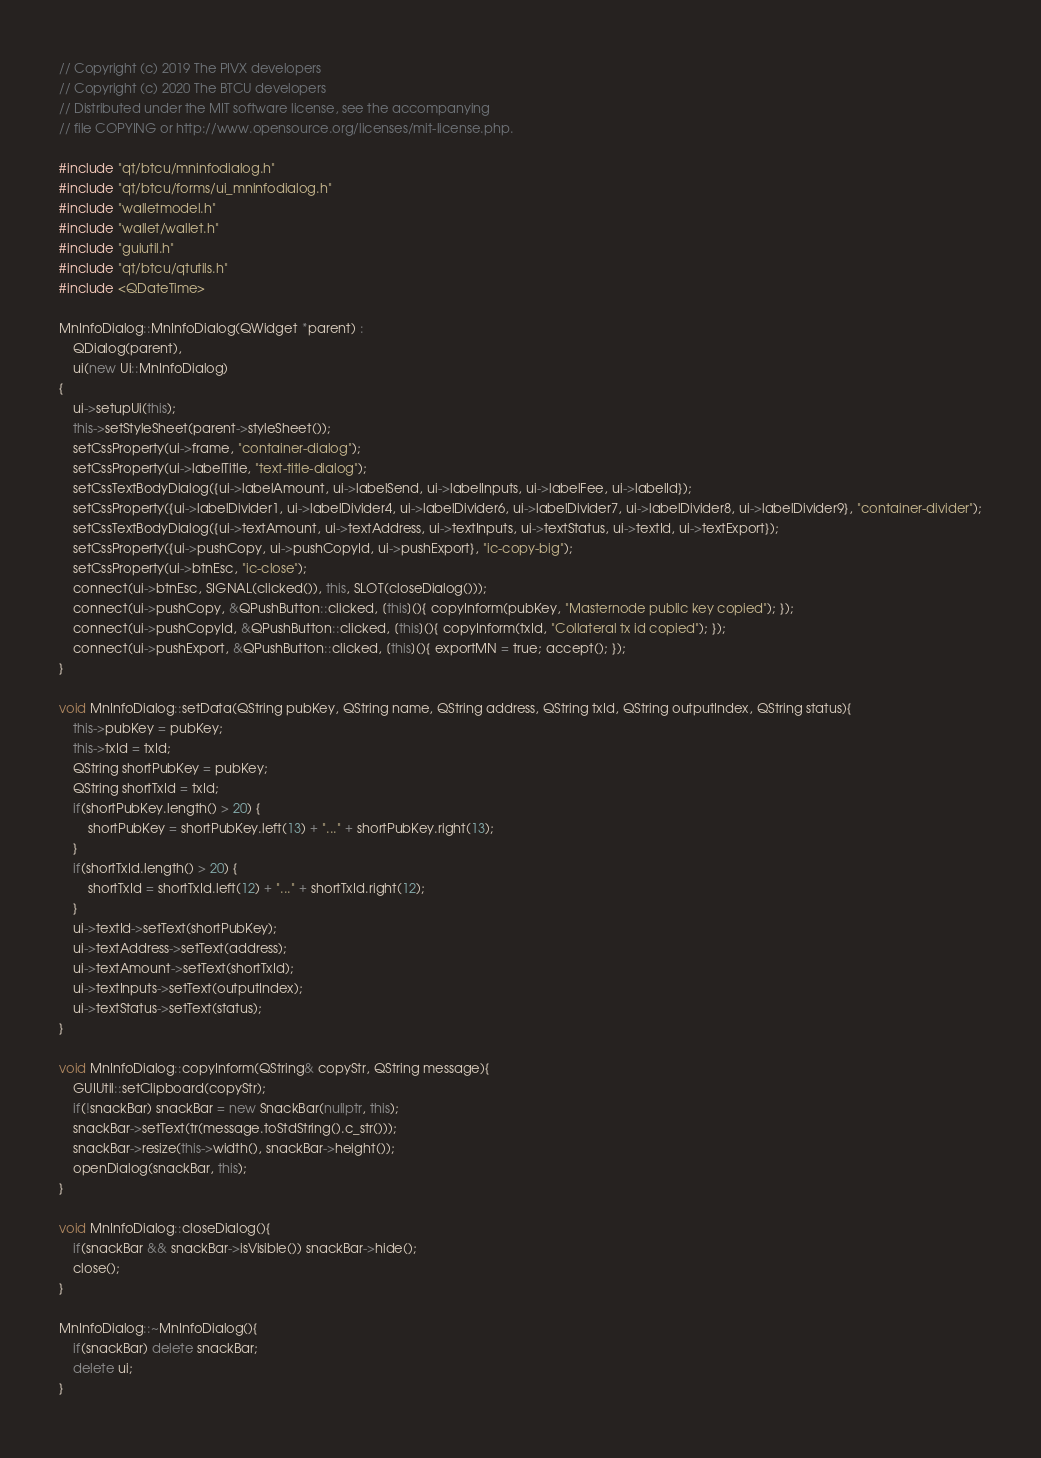<code> <loc_0><loc_0><loc_500><loc_500><_C++_>// Copyright (c) 2019 The PIVX developers
// Copyright (c) 2020 The BTCU developers
// Distributed under the MIT software license, see the accompanying
// file COPYING or http://www.opensource.org/licenses/mit-license.php.

#include "qt/btcu/mninfodialog.h"
#include "qt/btcu/forms/ui_mninfodialog.h"
#include "walletmodel.h"
#include "wallet/wallet.h"
#include "guiutil.h"
#include "qt/btcu/qtutils.h"
#include <QDateTime>

MnInfoDialog::MnInfoDialog(QWidget *parent) :
    QDialog(parent),
    ui(new Ui::MnInfoDialog)
{
    ui->setupUi(this);
    this->setStyleSheet(parent->styleSheet());
    setCssProperty(ui->frame, "container-dialog");
    setCssProperty(ui->labelTitle, "text-title-dialog");
    setCssTextBodyDialog({ui->labelAmount, ui->labelSend, ui->labelInputs, ui->labelFee, ui->labelId});
    setCssProperty({ui->labelDivider1, ui->labelDivider4, ui->labelDivider6, ui->labelDivider7, ui->labelDivider8, ui->labelDivider9}, "container-divider");
    setCssTextBodyDialog({ui->textAmount, ui->textAddress, ui->textInputs, ui->textStatus, ui->textId, ui->textExport});
    setCssProperty({ui->pushCopy, ui->pushCopyId, ui->pushExport}, "ic-copy-big");
    setCssProperty(ui->btnEsc, "ic-close");
    connect(ui->btnEsc, SIGNAL(clicked()), this, SLOT(closeDialog()));
    connect(ui->pushCopy, &QPushButton::clicked, [this](){ copyInform(pubKey, "Masternode public key copied"); });
    connect(ui->pushCopyId, &QPushButton::clicked, [this](){ copyInform(txId, "Collateral tx id copied"); });
    connect(ui->pushExport, &QPushButton::clicked, [this](){ exportMN = true; accept(); });
}

void MnInfoDialog::setData(QString pubKey, QString name, QString address, QString txId, QString outputIndex, QString status){
    this->pubKey = pubKey;
    this->txId = txId;
    QString shortPubKey = pubKey;
    QString shortTxId = txId;
    if(shortPubKey.length() > 20) {
        shortPubKey = shortPubKey.left(13) + "..." + shortPubKey.right(13);
    }
    if(shortTxId.length() > 20) {
        shortTxId = shortTxId.left(12) + "..." + shortTxId.right(12);
    }
    ui->textId->setText(shortPubKey);
    ui->textAddress->setText(address);
    ui->textAmount->setText(shortTxId);
    ui->textInputs->setText(outputIndex);
    ui->textStatus->setText(status);
}

void MnInfoDialog::copyInform(QString& copyStr, QString message){
    GUIUtil::setClipboard(copyStr);
    if(!snackBar) snackBar = new SnackBar(nullptr, this);
    snackBar->setText(tr(message.toStdString().c_str()));
    snackBar->resize(this->width(), snackBar->height());
    openDialog(snackBar, this);
}

void MnInfoDialog::closeDialog(){
    if(snackBar && snackBar->isVisible()) snackBar->hide();
    close();
}

MnInfoDialog::~MnInfoDialog(){
    if(snackBar) delete snackBar;
    delete ui;
}
</code> 